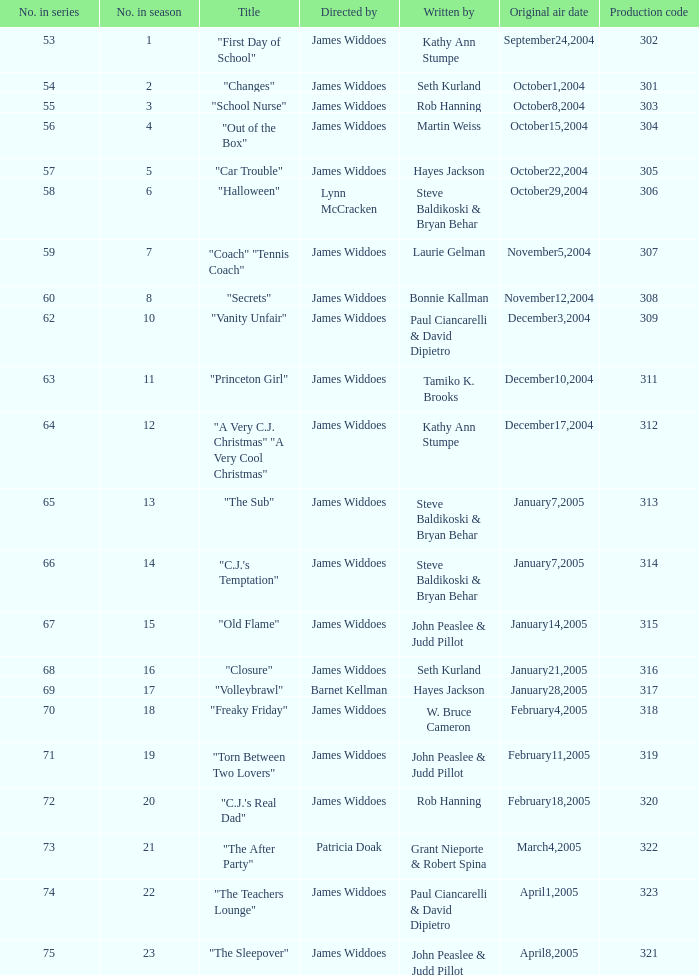What is the production code for episode 3 of the season? 303.0. 